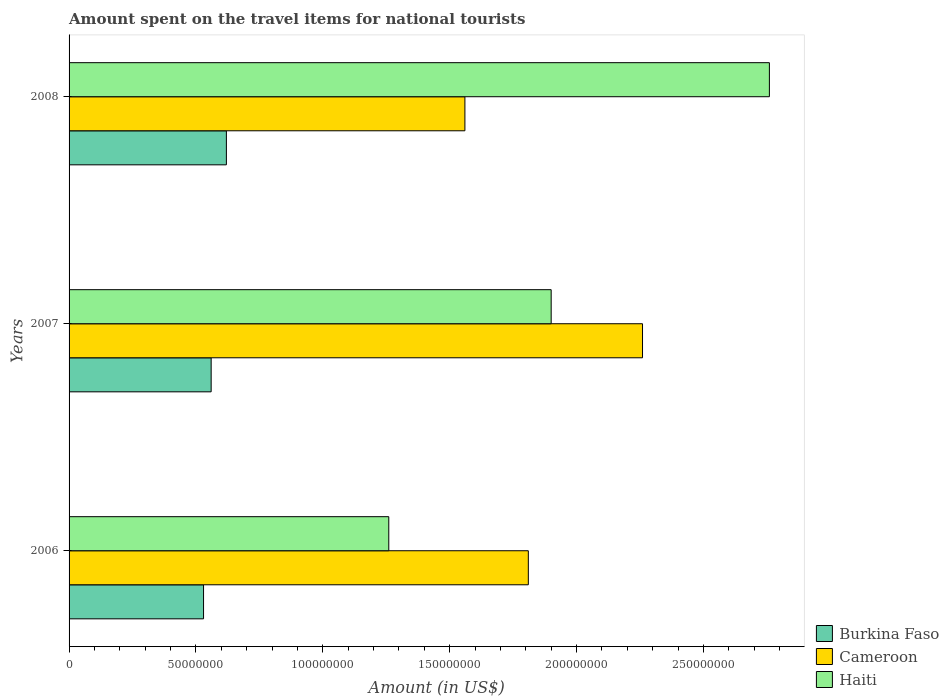How many different coloured bars are there?
Offer a very short reply. 3. How many groups of bars are there?
Your answer should be compact. 3. Are the number of bars per tick equal to the number of legend labels?
Provide a succinct answer. Yes. How many bars are there on the 3rd tick from the bottom?
Your answer should be very brief. 3. What is the label of the 3rd group of bars from the top?
Your answer should be compact. 2006. What is the amount spent on the travel items for national tourists in Cameroon in 2007?
Make the answer very short. 2.26e+08. Across all years, what is the maximum amount spent on the travel items for national tourists in Burkina Faso?
Give a very brief answer. 6.20e+07. Across all years, what is the minimum amount spent on the travel items for national tourists in Cameroon?
Offer a terse response. 1.56e+08. What is the total amount spent on the travel items for national tourists in Burkina Faso in the graph?
Keep it short and to the point. 1.71e+08. What is the difference between the amount spent on the travel items for national tourists in Cameroon in 2007 and that in 2008?
Provide a short and direct response. 7.00e+07. What is the difference between the amount spent on the travel items for national tourists in Cameroon in 2006 and the amount spent on the travel items for national tourists in Burkina Faso in 2007?
Your answer should be compact. 1.25e+08. What is the average amount spent on the travel items for national tourists in Cameroon per year?
Offer a terse response. 1.88e+08. In the year 2007, what is the difference between the amount spent on the travel items for national tourists in Cameroon and amount spent on the travel items for national tourists in Burkina Faso?
Your answer should be compact. 1.70e+08. In how many years, is the amount spent on the travel items for national tourists in Haiti greater than 200000000 US$?
Provide a short and direct response. 1. What is the ratio of the amount spent on the travel items for national tourists in Burkina Faso in 2007 to that in 2008?
Your answer should be very brief. 0.9. Is the amount spent on the travel items for national tourists in Cameroon in 2006 less than that in 2008?
Offer a very short reply. No. Is the difference between the amount spent on the travel items for national tourists in Cameroon in 2006 and 2007 greater than the difference between the amount spent on the travel items for national tourists in Burkina Faso in 2006 and 2007?
Provide a succinct answer. No. What is the difference between the highest and the second highest amount spent on the travel items for national tourists in Cameroon?
Provide a short and direct response. 4.50e+07. What is the difference between the highest and the lowest amount spent on the travel items for national tourists in Burkina Faso?
Keep it short and to the point. 9.00e+06. In how many years, is the amount spent on the travel items for national tourists in Burkina Faso greater than the average amount spent on the travel items for national tourists in Burkina Faso taken over all years?
Make the answer very short. 1. Is the sum of the amount spent on the travel items for national tourists in Haiti in 2006 and 2008 greater than the maximum amount spent on the travel items for national tourists in Cameroon across all years?
Your answer should be very brief. Yes. What does the 1st bar from the top in 2006 represents?
Give a very brief answer. Haiti. What does the 2nd bar from the bottom in 2008 represents?
Make the answer very short. Cameroon. Is it the case that in every year, the sum of the amount spent on the travel items for national tourists in Cameroon and amount spent on the travel items for national tourists in Burkina Faso is greater than the amount spent on the travel items for national tourists in Haiti?
Your answer should be compact. No. Are all the bars in the graph horizontal?
Your response must be concise. Yes. How many years are there in the graph?
Provide a short and direct response. 3. What is the difference between two consecutive major ticks on the X-axis?
Ensure brevity in your answer.  5.00e+07. Are the values on the major ticks of X-axis written in scientific E-notation?
Offer a very short reply. No. Does the graph contain grids?
Keep it short and to the point. No. Where does the legend appear in the graph?
Ensure brevity in your answer.  Bottom right. How many legend labels are there?
Offer a very short reply. 3. How are the legend labels stacked?
Your answer should be very brief. Vertical. What is the title of the graph?
Keep it short and to the point. Amount spent on the travel items for national tourists. Does "Argentina" appear as one of the legend labels in the graph?
Ensure brevity in your answer.  No. What is the Amount (in US$) in Burkina Faso in 2006?
Offer a very short reply. 5.30e+07. What is the Amount (in US$) of Cameroon in 2006?
Your response must be concise. 1.81e+08. What is the Amount (in US$) of Haiti in 2006?
Keep it short and to the point. 1.26e+08. What is the Amount (in US$) in Burkina Faso in 2007?
Offer a terse response. 5.60e+07. What is the Amount (in US$) of Cameroon in 2007?
Provide a short and direct response. 2.26e+08. What is the Amount (in US$) in Haiti in 2007?
Your response must be concise. 1.90e+08. What is the Amount (in US$) in Burkina Faso in 2008?
Offer a terse response. 6.20e+07. What is the Amount (in US$) of Cameroon in 2008?
Make the answer very short. 1.56e+08. What is the Amount (in US$) of Haiti in 2008?
Offer a very short reply. 2.76e+08. Across all years, what is the maximum Amount (in US$) of Burkina Faso?
Ensure brevity in your answer.  6.20e+07. Across all years, what is the maximum Amount (in US$) in Cameroon?
Offer a very short reply. 2.26e+08. Across all years, what is the maximum Amount (in US$) of Haiti?
Offer a terse response. 2.76e+08. Across all years, what is the minimum Amount (in US$) in Burkina Faso?
Provide a short and direct response. 5.30e+07. Across all years, what is the minimum Amount (in US$) of Cameroon?
Your answer should be very brief. 1.56e+08. Across all years, what is the minimum Amount (in US$) in Haiti?
Provide a short and direct response. 1.26e+08. What is the total Amount (in US$) of Burkina Faso in the graph?
Keep it short and to the point. 1.71e+08. What is the total Amount (in US$) of Cameroon in the graph?
Provide a short and direct response. 5.63e+08. What is the total Amount (in US$) of Haiti in the graph?
Make the answer very short. 5.92e+08. What is the difference between the Amount (in US$) of Burkina Faso in 2006 and that in 2007?
Your answer should be compact. -3.00e+06. What is the difference between the Amount (in US$) of Cameroon in 2006 and that in 2007?
Give a very brief answer. -4.50e+07. What is the difference between the Amount (in US$) of Haiti in 2006 and that in 2007?
Your response must be concise. -6.40e+07. What is the difference between the Amount (in US$) in Burkina Faso in 2006 and that in 2008?
Offer a terse response. -9.00e+06. What is the difference between the Amount (in US$) in Cameroon in 2006 and that in 2008?
Offer a terse response. 2.50e+07. What is the difference between the Amount (in US$) in Haiti in 2006 and that in 2008?
Your answer should be very brief. -1.50e+08. What is the difference between the Amount (in US$) in Burkina Faso in 2007 and that in 2008?
Provide a succinct answer. -6.00e+06. What is the difference between the Amount (in US$) in Cameroon in 2007 and that in 2008?
Ensure brevity in your answer.  7.00e+07. What is the difference between the Amount (in US$) in Haiti in 2007 and that in 2008?
Your response must be concise. -8.60e+07. What is the difference between the Amount (in US$) of Burkina Faso in 2006 and the Amount (in US$) of Cameroon in 2007?
Your answer should be very brief. -1.73e+08. What is the difference between the Amount (in US$) in Burkina Faso in 2006 and the Amount (in US$) in Haiti in 2007?
Your answer should be very brief. -1.37e+08. What is the difference between the Amount (in US$) of Cameroon in 2006 and the Amount (in US$) of Haiti in 2007?
Provide a succinct answer. -9.00e+06. What is the difference between the Amount (in US$) in Burkina Faso in 2006 and the Amount (in US$) in Cameroon in 2008?
Give a very brief answer. -1.03e+08. What is the difference between the Amount (in US$) of Burkina Faso in 2006 and the Amount (in US$) of Haiti in 2008?
Your answer should be very brief. -2.23e+08. What is the difference between the Amount (in US$) in Cameroon in 2006 and the Amount (in US$) in Haiti in 2008?
Your response must be concise. -9.50e+07. What is the difference between the Amount (in US$) of Burkina Faso in 2007 and the Amount (in US$) of Cameroon in 2008?
Make the answer very short. -1.00e+08. What is the difference between the Amount (in US$) in Burkina Faso in 2007 and the Amount (in US$) in Haiti in 2008?
Your answer should be compact. -2.20e+08. What is the difference between the Amount (in US$) of Cameroon in 2007 and the Amount (in US$) of Haiti in 2008?
Your response must be concise. -5.00e+07. What is the average Amount (in US$) in Burkina Faso per year?
Your answer should be compact. 5.70e+07. What is the average Amount (in US$) in Cameroon per year?
Provide a succinct answer. 1.88e+08. What is the average Amount (in US$) in Haiti per year?
Give a very brief answer. 1.97e+08. In the year 2006, what is the difference between the Amount (in US$) in Burkina Faso and Amount (in US$) in Cameroon?
Your response must be concise. -1.28e+08. In the year 2006, what is the difference between the Amount (in US$) of Burkina Faso and Amount (in US$) of Haiti?
Your answer should be compact. -7.30e+07. In the year 2006, what is the difference between the Amount (in US$) of Cameroon and Amount (in US$) of Haiti?
Your response must be concise. 5.50e+07. In the year 2007, what is the difference between the Amount (in US$) in Burkina Faso and Amount (in US$) in Cameroon?
Your answer should be compact. -1.70e+08. In the year 2007, what is the difference between the Amount (in US$) of Burkina Faso and Amount (in US$) of Haiti?
Ensure brevity in your answer.  -1.34e+08. In the year 2007, what is the difference between the Amount (in US$) in Cameroon and Amount (in US$) in Haiti?
Offer a terse response. 3.60e+07. In the year 2008, what is the difference between the Amount (in US$) in Burkina Faso and Amount (in US$) in Cameroon?
Keep it short and to the point. -9.40e+07. In the year 2008, what is the difference between the Amount (in US$) in Burkina Faso and Amount (in US$) in Haiti?
Keep it short and to the point. -2.14e+08. In the year 2008, what is the difference between the Amount (in US$) of Cameroon and Amount (in US$) of Haiti?
Give a very brief answer. -1.20e+08. What is the ratio of the Amount (in US$) in Burkina Faso in 2006 to that in 2007?
Your answer should be compact. 0.95. What is the ratio of the Amount (in US$) of Cameroon in 2006 to that in 2007?
Keep it short and to the point. 0.8. What is the ratio of the Amount (in US$) of Haiti in 2006 to that in 2007?
Offer a very short reply. 0.66. What is the ratio of the Amount (in US$) of Burkina Faso in 2006 to that in 2008?
Ensure brevity in your answer.  0.85. What is the ratio of the Amount (in US$) of Cameroon in 2006 to that in 2008?
Provide a succinct answer. 1.16. What is the ratio of the Amount (in US$) in Haiti in 2006 to that in 2008?
Offer a terse response. 0.46. What is the ratio of the Amount (in US$) of Burkina Faso in 2007 to that in 2008?
Ensure brevity in your answer.  0.9. What is the ratio of the Amount (in US$) of Cameroon in 2007 to that in 2008?
Offer a terse response. 1.45. What is the ratio of the Amount (in US$) in Haiti in 2007 to that in 2008?
Your response must be concise. 0.69. What is the difference between the highest and the second highest Amount (in US$) in Burkina Faso?
Your answer should be compact. 6.00e+06. What is the difference between the highest and the second highest Amount (in US$) in Cameroon?
Ensure brevity in your answer.  4.50e+07. What is the difference between the highest and the second highest Amount (in US$) in Haiti?
Offer a terse response. 8.60e+07. What is the difference between the highest and the lowest Amount (in US$) of Burkina Faso?
Your answer should be compact. 9.00e+06. What is the difference between the highest and the lowest Amount (in US$) in Cameroon?
Offer a terse response. 7.00e+07. What is the difference between the highest and the lowest Amount (in US$) in Haiti?
Your response must be concise. 1.50e+08. 